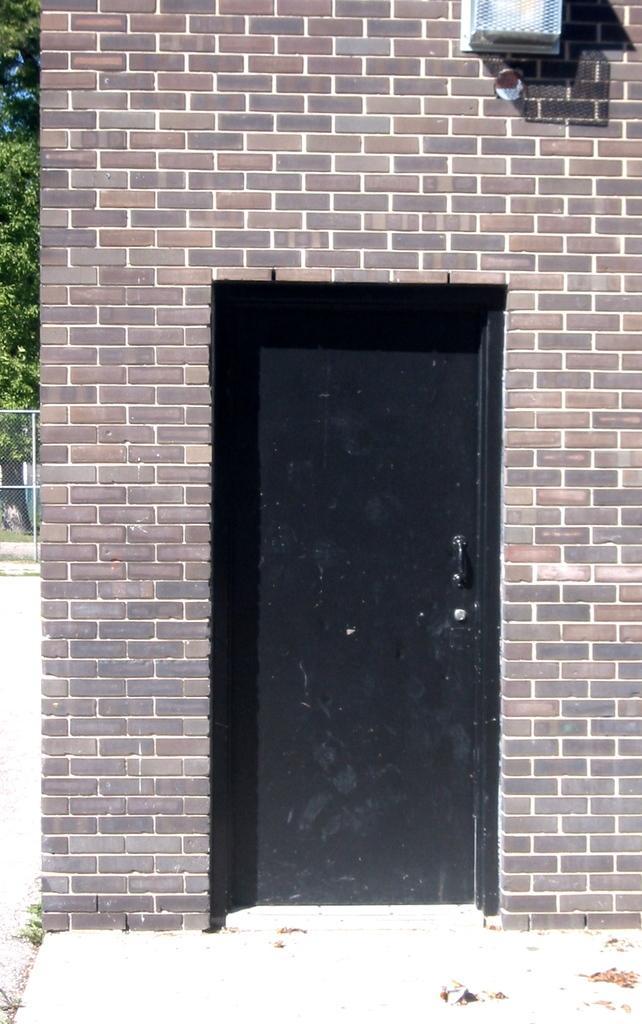Could you give a brief overview of what you see in this image? In this picture we can see object on the wall and door. In the background of the image we can see mesh and leaves. 